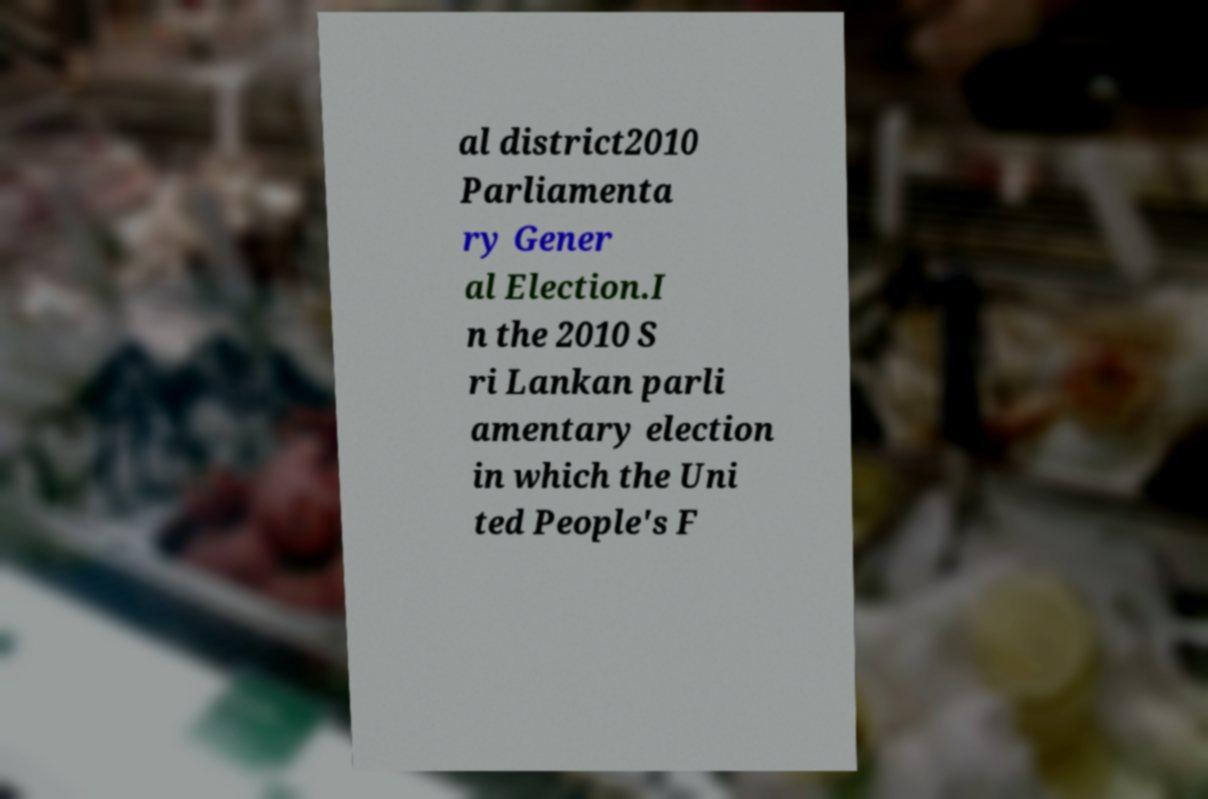Please read and relay the text visible in this image. What does it say? al district2010 Parliamenta ry Gener al Election.I n the 2010 S ri Lankan parli amentary election in which the Uni ted People's F 